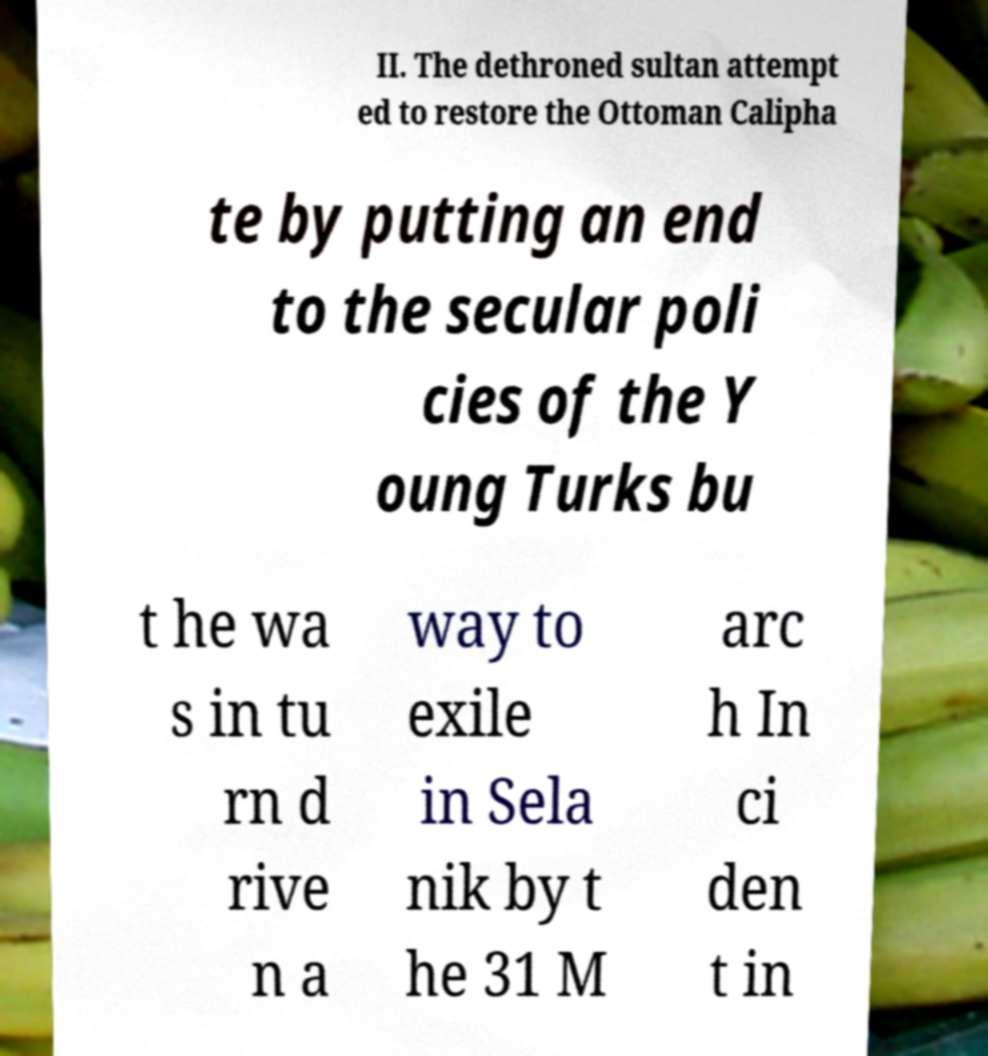There's text embedded in this image that I need extracted. Can you transcribe it verbatim? II. The dethroned sultan attempt ed to restore the Ottoman Calipha te by putting an end to the secular poli cies of the Y oung Turks bu t he wa s in tu rn d rive n a way to exile in Sela nik by t he 31 M arc h In ci den t in 